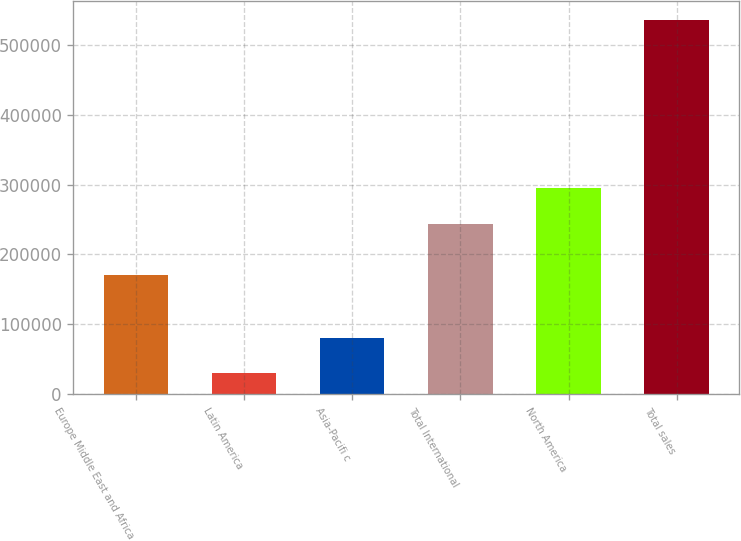Convert chart. <chart><loc_0><loc_0><loc_500><loc_500><bar_chart><fcel>Europe Middle East and Africa<fcel>Latin America<fcel>Asia-Pacifi c<fcel>Total International<fcel>North America<fcel>Total sales<nl><fcel>170544<fcel>29406<fcel>80105.1<fcel>243854<fcel>294553<fcel>536397<nl></chart> 